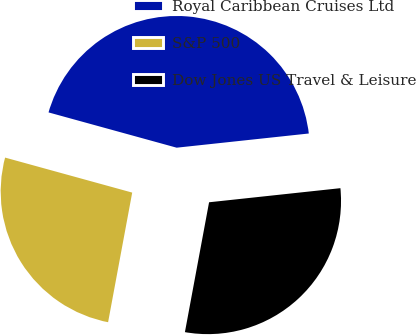<chart> <loc_0><loc_0><loc_500><loc_500><pie_chart><fcel>Royal Caribbean Cruises Ltd<fcel>S&P 500<fcel>Dow Jones US Travel & Leisure<nl><fcel>44.02%<fcel>26.35%<fcel>29.63%<nl></chart> 